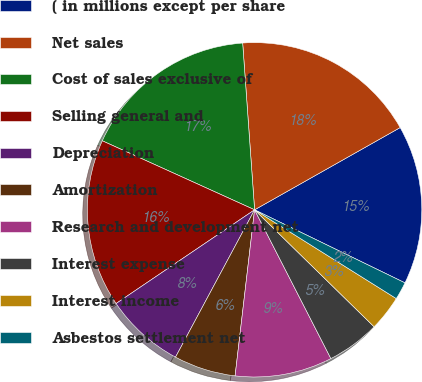Convert chart to OTSL. <chart><loc_0><loc_0><loc_500><loc_500><pie_chart><fcel>( in millions except per share<fcel>Net sales<fcel>Cost of sales exclusive of<fcel>Selling general and<fcel>Depreciation<fcel>Amortization<fcel>Research and development net<fcel>Interest expense<fcel>Interest income<fcel>Asbestos settlement net<nl><fcel>15.38%<fcel>17.95%<fcel>17.09%<fcel>16.24%<fcel>7.69%<fcel>5.98%<fcel>9.4%<fcel>5.13%<fcel>3.42%<fcel>1.71%<nl></chart> 